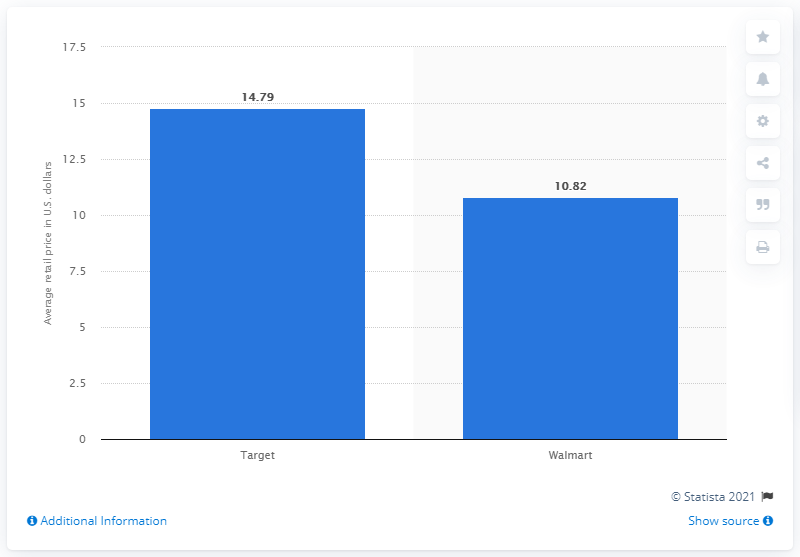Outline some significant characteristics in this image. In 2018, Walmart's average retail price was 10.82. In 2018, the average retail price of apparel at Target was 14.79. 